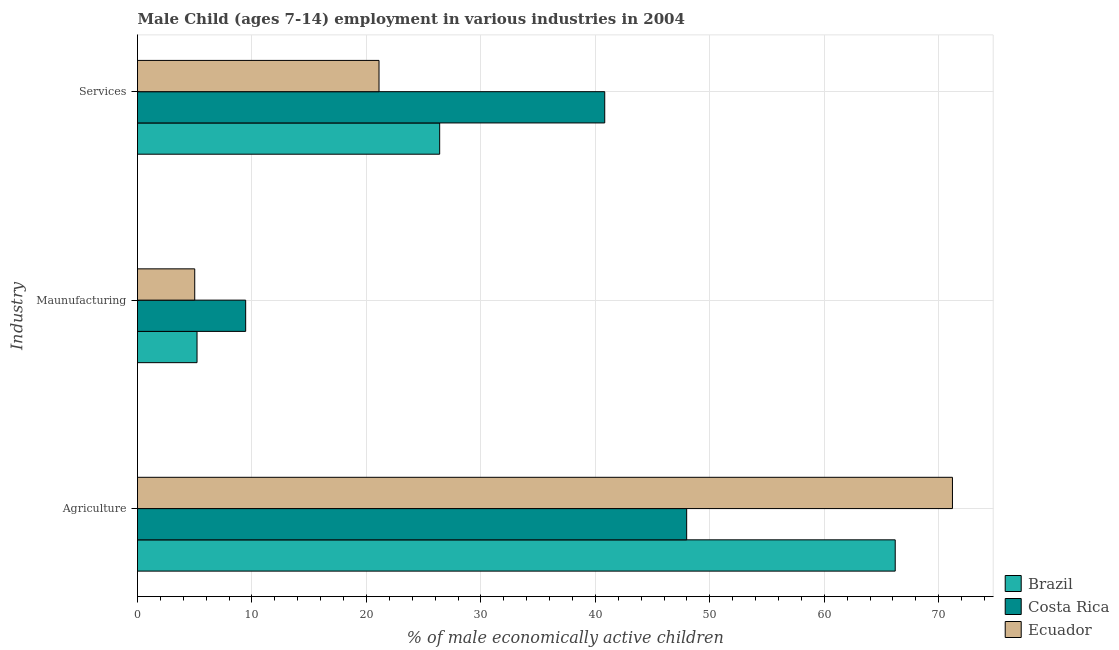How many different coloured bars are there?
Your answer should be very brief. 3. Are the number of bars per tick equal to the number of legend labels?
Your answer should be very brief. Yes. Are the number of bars on each tick of the Y-axis equal?
Your response must be concise. Yes. What is the label of the 2nd group of bars from the top?
Your answer should be very brief. Maunufacturing. What is the percentage of economically active children in agriculture in Brazil?
Provide a succinct answer. 66.2. Across all countries, what is the maximum percentage of economically active children in services?
Offer a very short reply. 40.82. Across all countries, what is the minimum percentage of economically active children in agriculture?
Make the answer very short. 47.98. In which country was the percentage of economically active children in services maximum?
Ensure brevity in your answer.  Costa Rica. What is the total percentage of economically active children in services in the graph?
Give a very brief answer. 88.32. What is the difference between the percentage of economically active children in services in Costa Rica and that in Ecuador?
Ensure brevity in your answer.  19.72. What is the difference between the percentage of economically active children in services in Brazil and the percentage of economically active children in manufacturing in Costa Rica?
Your answer should be compact. 16.95. What is the average percentage of economically active children in services per country?
Your answer should be compact. 29.44. What is the difference between the percentage of economically active children in manufacturing and percentage of economically active children in services in Ecuador?
Your response must be concise. -16.1. In how many countries, is the percentage of economically active children in services greater than 2 %?
Your response must be concise. 3. What is the ratio of the percentage of economically active children in manufacturing in Brazil to that in Ecuador?
Your answer should be compact. 1.04. Is the percentage of economically active children in agriculture in Ecuador less than that in Costa Rica?
Your response must be concise. No. Is the difference between the percentage of economically active children in manufacturing in Costa Rica and Ecuador greater than the difference between the percentage of economically active children in agriculture in Costa Rica and Ecuador?
Your answer should be compact. Yes. What is the difference between the highest and the second highest percentage of economically active children in manufacturing?
Give a very brief answer. 4.25. What is the difference between the highest and the lowest percentage of economically active children in manufacturing?
Your answer should be compact. 4.45. Is the sum of the percentage of economically active children in manufacturing in Ecuador and Costa Rica greater than the maximum percentage of economically active children in services across all countries?
Your response must be concise. No. What does the 3rd bar from the top in Maunufacturing represents?
Your response must be concise. Brazil. Is it the case that in every country, the sum of the percentage of economically active children in agriculture and percentage of economically active children in manufacturing is greater than the percentage of economically active children in services?
Provide a short and direct response. Yes. Are all the bars in the graph horizontal?
Offer a terse response. Yes. What is the difference between two consecutive major ticks on the X-axis?
Offer a terse response. 10. How many legend labels are there?
Make the answer very short. 3. How are the legend labels stacked?
Ensure brevity in your answer.  Vertical. What is the title of the graph?
Provide a succinct answer. Male Child (ages 7-14) employment in various industries in 2004. Does "Honduras" appear as one of the legend labels in the graph?
Your answer should be compact. No. What is the label or title of the X-axis?
Your answer should be very brief. % of male economically active children. What is the label or title of the Y-axis?
Make the answer very short. Industry. What is the % of male economically active children of Brazil in Agriculture?
Give a very brief answer. 66.2. What is the % of male economically active children in Costa Rica in Agriculture?
Provide a succinct answer. 47.98. What is the % of male economically active children in Ecuador in Agriculture?
Your answer should be compact. 71.2. What is the % of male economically active children of Costa Rica in Maunufacturing?
Keep it short and to the point. 9.45. What is the % of male economically active children of Brazil in Services?
Provide a short and direct response. 26.4. What is the % of male economically active children in Costa Rica in Services?
Ensure brevity in your answer.  40.82. What is the % of male economically active children in Ecuador in Services?
Provide a succinct answer. 21.1. Across all Industry, what is the maximum % of male economically active children of Brazil?
Provide a short and direct response. 66.2. Across all Industry, what is the maximum % of male economically active children in Costa Rica?
Give a very brief answer. 47.98. Across all Industry, what is the maximum % of male economically active children in Ecuador?
Provide a short and direct response. 71.2. Across all Industry, what is the minimum % of male economically active children in Costa Rica?
Your answer should be compact. 9.45. Across all Industry, what is the minimum % of male economically active children in Ecuador?
Provide a succinct answer. 5. What is the total % of male economically active children of Brazil in the graph?
Provide a short and direct response. 97.8. What is the total % of male economically active children in Costa Rica in the graph?
Ensure brevity in your answer.  98.25. What is the total % of male economically active children in Ecuador in the graph?
Offer a terse response. 97.3. What is the difference between the % of male economically active children in Costa Rica in Agriculture and that in Maunufacturing?
Keep it short and to the point. 38.53. What is the difference between the % of male economically active children in Ecuador in Agriculture and that in Maunufacturing?
Your response must be concise. 66.2. What is the difference between the % of male economically active children of Brazil in Agriculture and that in Services?
Offer a terse response. 39.8. What is the difference between the % of male economically active children of Costa Rica in Agriculture and that in Services?
Offer a very short reply. 7.16. What is the difference between the % of male economically active children of Ecuador in Agriculture and that in Services?
Offer a terse response. 50.1. What is the difference between the % of male economically active children in Brazil in Maunufacturing and that in Services?
Make the answer very short. -21.2. What is the difference between the % of male economically active children of Costa Rica in Maunufacturing and that in Services?
Ensure brevity in your answer.  -31.37. What is the difference between the % of male economically active children of Ecuador in Maunufacturing and that in Services?
Your response must be concise. -16.1. What is the difference between the % of male economically active children in Brazil in Agriculture and the % of male economically active children in Costa Rica in Maunufacturing?
Your answer should be compact. 56.75. What is the difference between the % of male economically active children of Brazil in Agriculture and the % of male economically active children of Ecuador in Maunufacturing?
Offer a very short reply. 61.2. What is the difference between the % of male economically active children of Costa Rica in Agriculture and the % of male economically active children of Ecuador in Maunufacturing?
Offer a very short reply. 42.98. What is the difference between the % of male economically active children of Brazil in Agriculture and the % of male economically active children of Costa Rica in Services?
Provide a short and direct response. 25.38. What is the difference between the % of male economically active children of Brazil in Agriculture and the % of male economically active children of Ecuador in Services?
Give a very brief answer. 45.1. What is the difference between the % of male economically active children in Costa Rica in Agriculture and the % of male economically active children in Ecuador in Services?
Keep it short and to the point. 26.88. What is the difference between the % of male economically active children of Brazil in Maunufacturing and the % of male economically active children of Costa Rica in Services?
Offer a terse response. -35.62. What is the difference between the % of male economically active children in Brazil in Maunufacturing and the % of male economically active children in Ecuador in Services?
Make the answer very short. -15.9. What is the difference between the % of male economically active children in Costa Rica in Maunufacturing and the % of male economically active children in Ecuador in Services?
Your answer should be compact. -11.65. What is the average % of male economically active children of Brazil per Industry?
Give a very brief answer. 32.6. What is the average % of male economically active children of Costa Rica per Industry?
Offer a terse response. 32.75. What is the average % of male economically active children in Ecuador per Industry?
Your answer should be compact. 32.43. What is the difference between the % of male economically active children of Brazil and % of male economically active children of Costa Rica in Agriculture?
Your answer should be compact. 18.22. What is the difference between the % of male economically active children of Costa Rica and % of male economically active children of Ecuador in Agriculture?
Keep it short and to the point. -23.22. What is the difference between the % of male economically active children of Brazil and % of male economically active children of Costa Rica in Maunufacturing?
Offer a terse response. -4.25. What is the difference between the % of male economically active children in Costa Rica and % of male economically active children in Ecuador in Maunufacturing?
Offer a very short reply. 4.45. What is the difference between the % of male economically active children in Brazil and % of male economically active children in Costa Rica in Services?
Provide a succinct answer. -14.42. What is the difference between the % of male economically active children in Brazil and % of male economically active children in Ecuador in Services?
Offer a very short reply. 5.3. What is the difference between the % of male economically active children of Costa Rica and % of male economically active children of Ecuador in Services?
Offer a very short reply. 19.72. What is the ratio of the % of male economically active children in Brazil in Agriculture to that in Maunufacturing?
Keep it short and to the point. 12.73. What is the ratio of the % of male economically active children in Costa Rica in Agriculture to that in Maunufacturing?
Offer a terse response. 5.08. What is the ratio of the % of male economically active children in Ecuador in Agriculture to that in Maunufacturing?
Your response must be concise. 14.24. What is the ratio of the % of male economically active children of Brazil in Agriculture to that in Services?
Your answer should be very brief. 2.51. What is the ratio of the % of male economically active children in Costa Rica in Agriculture to that in Services?
Offer a very short reply. 1.18. What is the ratio of the % of male economically active children of Ecuador in Agriculture to that in Services?
Your answer should be very brief. 3.37. What is the ratio of the % of male economically active children of Brazil in Maunufacturing to that in Services?
Offer a very short reply. 0.2. What is the ratio of the % of male economically active children in Costa Rica in Maunufacturing to that in Services?
Your answer should be compact. 0.23. What is the ratio of the % of male economically active children of Ecuador in Maunufacturing to that in Services?
Your answer should be compact. 0.24. What is the difference between the highest and the second highest % of male economically active children in Brazil?
Provide a short and direct response. 39.8. What is the difference between the highest and the second highest % of male economically active children of Costa Rica?
Your answer should be very brief. 7.16. What is the difference between the highest and the second highest % of male economically active children of Ecuador?
Give a very brief answer. 50.1. What is the difference between the highest and the lowest % of male economically active children of Brazil?
Offer a very short reply. 61. What is the difference between the highest and the lowest % of male economically active children of Costa Rica?
Offer a terse response. 38.53. What is the difference between the highest and the lowest % of male economically active children in Ecuador?
Ensure brevity in your answer.  66.2. 